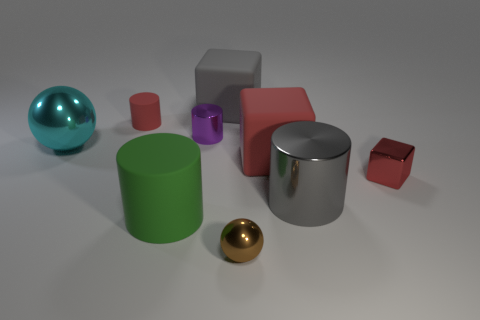Subtract all yellow cylinders. Subtract all green balls. How many cylinders are left? 4 Add 1 small brown objects. How many objects exist? 10 Subtract all cylinders. How many objects are left? 5 Subtract 0 gray spheres. How many objects are left? 9 Subtract all large blue matte cylinders. Subtract all brown things. How many objects are left? 8 Add 4 tiny metallic cylinders. How many tiny metallic cylinders are left? 5 Add 6 blue matte balls. How many blue matte balls exist? 6 